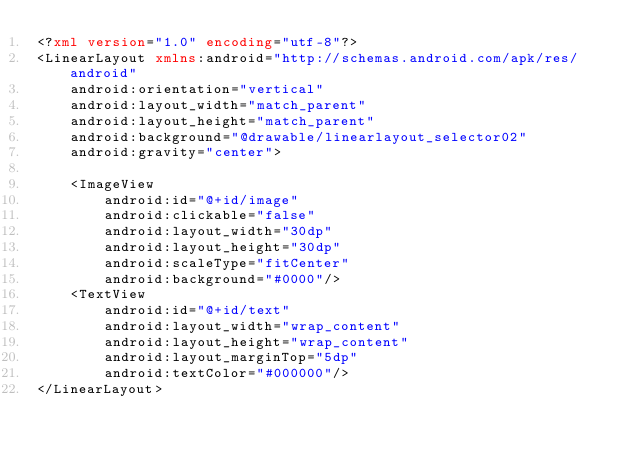Convert code to text. <code><loc_0><loc_0><loc_500><loc_500><_XML_><?xml version="1.0" encoding="utf-8"?>
<LinearLayout xmlns:android="http://schemas.android.com/apk/res/android"
    android:orientation="vertical"
    android:layout_width="match_parent"
    android:layout_height="match_parent"
    android:background="@drawable/linearlayout_selector02"
    android:gravity="center">

    <ImageView
        android:id="@+id/image"
        android:clickable="false"
        android:layout_width="30dp"
        android:layout_height="30dp"
        android:scaleType="fitCenter"
        android:background="#0000"/>
    <TextView
        android:id="@+id/text"
        android:layout_width="wrap_content"
        android:layout_height="wrap_content"
        android:layout_marginTop="5dp"
        android:textColor="#000000"/>
</LinearLayout></code> 